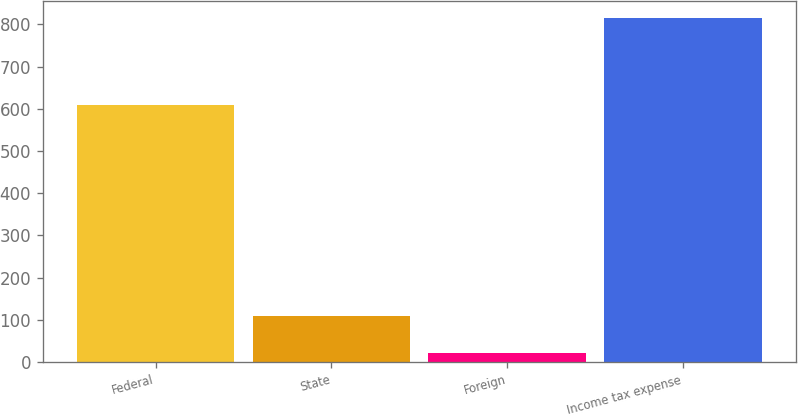Convert chart to OTSL. <chart><loc_0><loc_0><loc_500><loc_500><bar_chart><fcel>Federal<fcel>State<fcel>Foreign<fcel>Income tax expense<nl><fcel>609<fcel>110<fcel>22<fcel>815<nl></chart> 